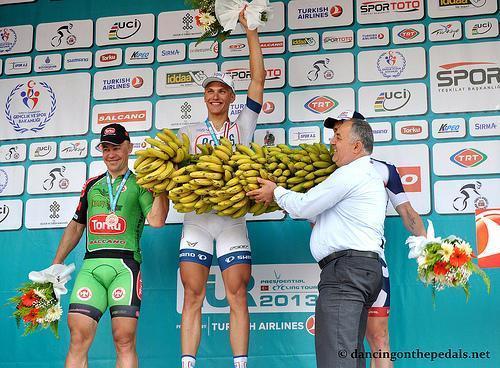How many people on the stage?
Give a very brief answer. 4. 